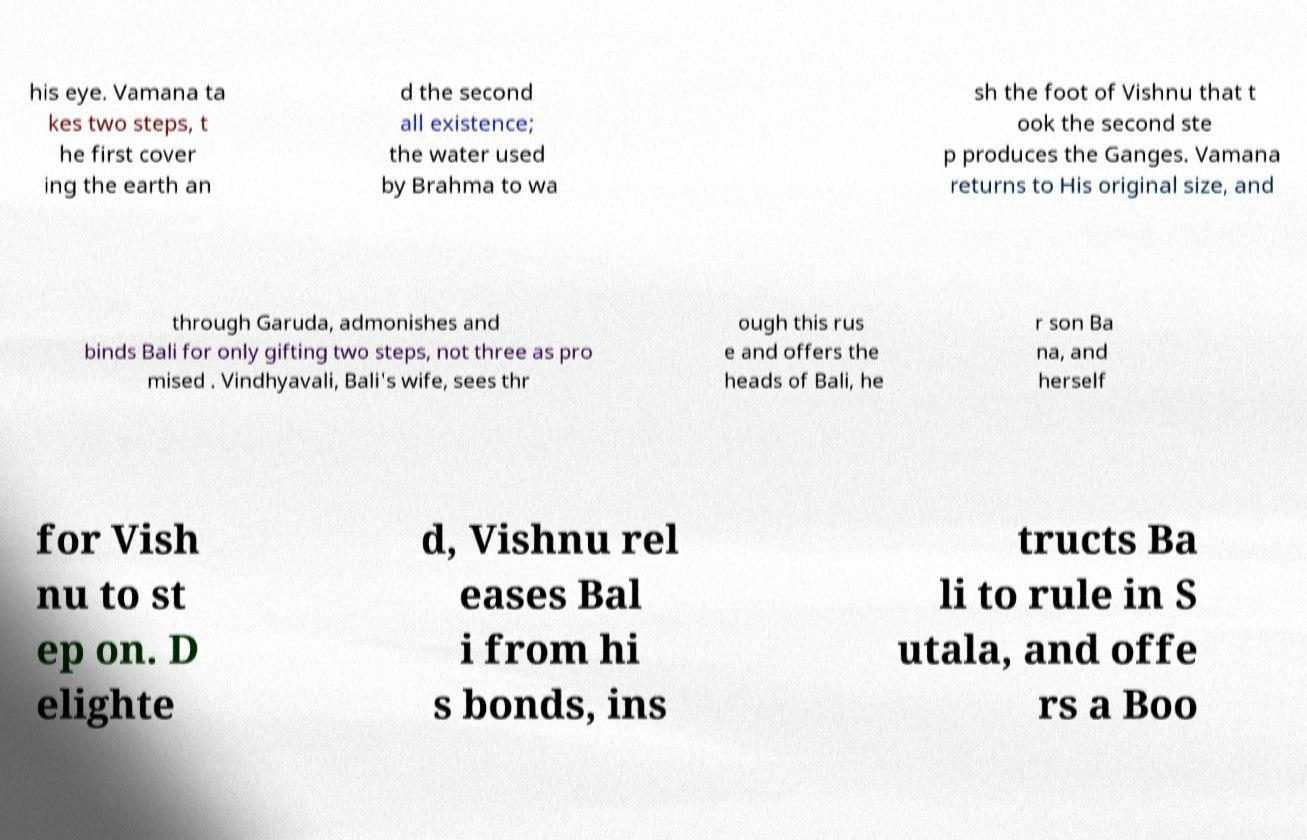Can you read and provide the text displayed in the image?This photo seems to have some interesting text. Can you extract and type it out for me? his eye. Vamana ta kes two steps, t he first cover ing the earth an d the second all existence; the water used by Brahma to wa sh the foot of Vishnu that t ook the second ste p produces the Ganges. Vamana returns to His original size, and through Garuda, admonishes and binds Bali for only gifting two steps, not three as pro mised . Vindhyavali, Bali's wife, sees thr ough this rus e and offers the heads of Bali, he r son Ba na, and herself for Vish nu to st ep on. D elighte d, Vishnu rel eases Bal i from hi s bonds, ins tructs Ba li to rule in S utala, and offe rs a Boo 